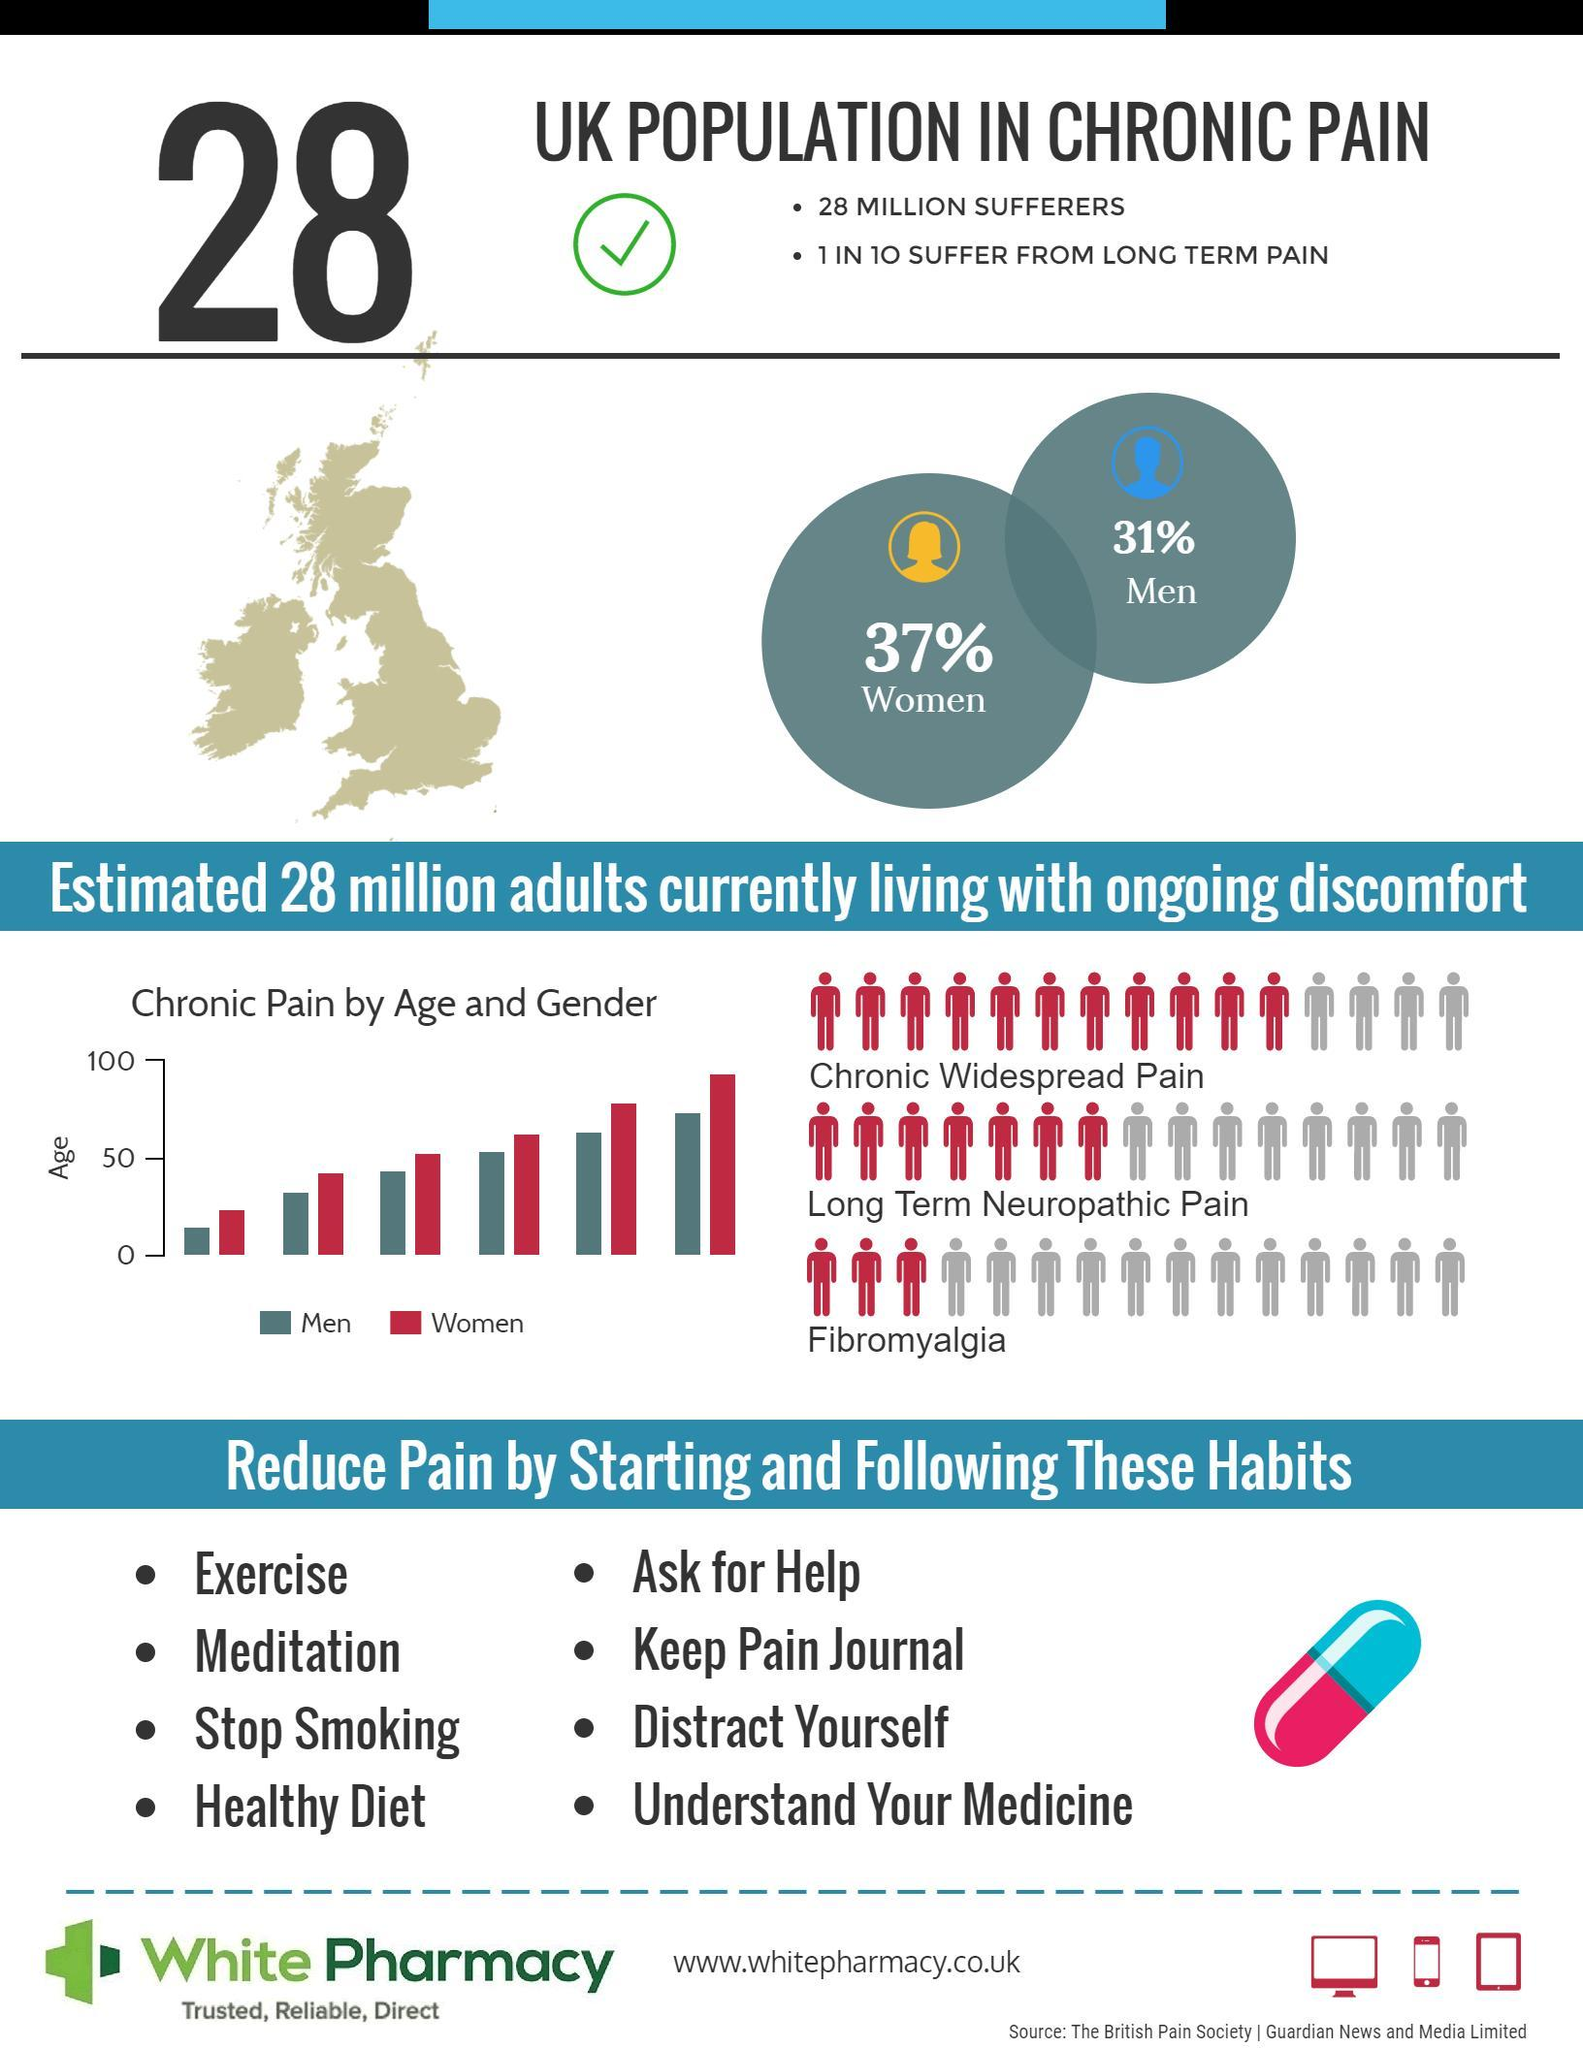What percentage of women in UK suffer from the chronic pain?
Answer the question with a short phrase. 37% What percentage of men in UK suffer from the chronic pain? 31% How many people in UK suffer from the chronic pain? 28 MILLION 